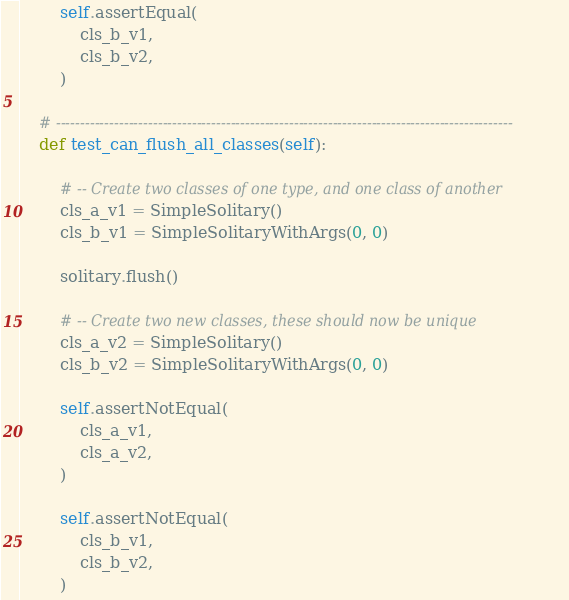Convert code to text. <code><loc_0><loc_0><loc_500><loc_500><_Python_>        self.assertEqual(
            cls_b_v1,
            cls_b_v2,
        )

    # ----------------------------------------------------------------------------------------------
    def test_can_flush_all_classes(self):

        # -- Create two classes of one type, and one class of another
        cls_a_v1 = SimpleSolitary()
        cls_b_v1 = SimpleSolitaryWithArgs(0, 0)

        solitary.flush()

        # -- Create two new classes, these should now be unique
        cls_a_v2 = SimpleSolitary()
        cls_b_v2 = SimpleSolitaryWithArgs(0, 0)

        self.assertNotEqual(
            cls_a_v1,
            cls_a_v2,
        )

        self.assertNotEqual(
            cls_b_v1,
            cls_b_v2,
        )
</code> 